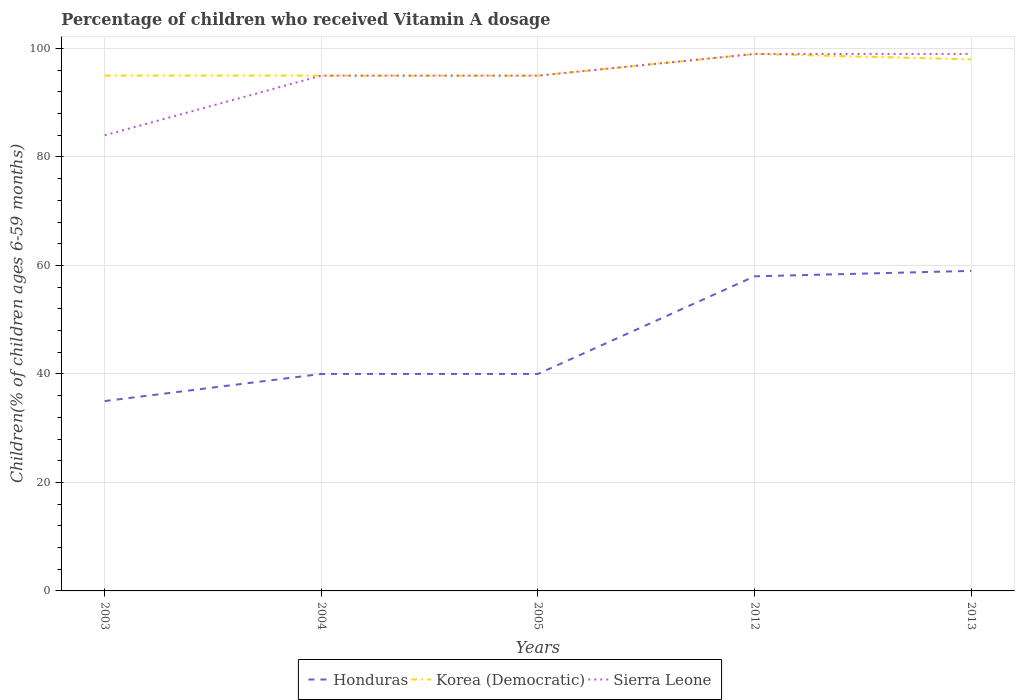How many different coloured lines are there?
Offer a very short reply. 3. Across all years, what is the maximum percentage of children who received Vitamin A dosage in Korea (Democratic)?
Give a very brief answer. 95. What is the total percentage of children who received Vitamin A dosage in Korea (Democratic) in the graph?
Provide a succinct answer. -4. What is the difference between the highest and the lowest percentage of children who received Vitamin A dosage in Korea (Democratic)?
Make the answer very short. 2. Is the percentage of children who received Vitamin A dosage in Sierra Leone strictly greater than the percentage of children who received Vitamin A dosage in Korea (Democratic) over the years?
Offer a terse response. No. How many years are there in the graph?
Your response must be concise. 5. Where does the legend appear in the graph?
Your answer should be very brief. Bottom center. What is the title of the graph?
Your answer should be compact. Percentage of children who received Vitamin A dosage. Does "Namibia" appear as one of the legend labels in the graph?
Offer a very short reply. No. What is the label or title of the X-axis?
Provide a short and direct response. Years. What is the label or title of the Y-axis?
Keep it short and to the point. Children(% of children ages 6-59 months). What is the Children(% of children ages 6-59 months) in Honduras in 2003?
Provide a short and direct response. 35. What is the Children(% of children ages 6-59 months) in Honduras in 2004?
Provide a succinct answer. 40. What is the Children(% of children ages 6-59 months) in Korea (Democratic) in 2004?
Offer a very short reply. 95. What is the Children(% of children ages 6-59 months) of Sierra Leone in 2004?
Keep it short and to the point. 95. What is the Children(% of children ages 6-59 months) in Sierra Leone in 2005?
Make the answer very short. 95. What is the Children(% of children ages 6-59 months) of Honduras in 2012?
Ensure brevity in your answer.  58. What is the Children(% of children ages 6-59 months) in Sierra Leone in 2012?
Provide a succinct answer. 99. What is the Children(% of children ages 6-59 months) of Honduras in 2013?
Your answer should be very brief. 59. What is the Children(% of children ages 6-59 months) of Korea (Democratic) in 2013?
Your response must be concise. 98. Across all years, what is the maximum Children(% of children ages 6-59 months) in Honduras?
Your answer should be compact. 59. Across all years, what is the maximum Children(% of children ages 6-59 months) in Korea (Democratic)?
Give a very brief answer. 99. Across all years, what is the minimum Children(% of children ages 6-59 months) of Honduras?
Ensure brevity in your answer.  35. Across all years, what is the minimum Children(% of children ages 6-59 months) in Korea (Democratic)?
Offer a terse response. 95. What is the total Children(% of children ages 6-59 months) of Honduras in the graph?
Offer a terse response. 232. What is the total Children(% of children ages 6-59 months) of Korea (Democratic) in the graph?
Make the answer very short. 482. What is the total Children(% of children ages 6-59 months) in Sierra Leone in the graph?
Provide a short and direct response. 472. What is the difference between the Children(% of children ages 6-59 months) in Korea (Democratic) in 2003 and that in 2004?
Provide a succinct answer. 0. What is the difference between the Children(% of children ages 6-59 months) in Honduras in 2003 and that in 2005?
Your answer should be compact. -5. What is the difference between the Children(% of children ages 6-59 months) in Sierra Leone in 2003 and that in 2005?
Your response must be concise. -11. What is the difference between the Children(% of children ages 6-59 months) in Honduras in 2003 and that in 2012?
Your response must be concise. -23. What is the difference between the Children(% of children ages 6-59 months) in Korea (Democratic) in 2003 and that in 2012?
Your answer should be compact. -4. What is the difference between the Children(% of children ages 6-59 months) in Honduras in 2003 and that in 2013?
Offer a terse response. -24. What is the difference between the Children(% of children ages 6-59 months) of Honduras in 2004 and that in 2005?
Provide a succinct answer. 0. What is the difference between the Children(% of children ages 6-59 months) of Sierra Leone in 2004 and that in 2005?
Make the answer very short. 0. What is the difference between the Children(% of children ages 6-59 months) in Korea (Democratic) in 2004 and that in 2012?
Offer a terse response. -4. What is the difference between the Children(% of children ages 6-59 months) of Sierra Leone in 2004 and that in 2012?
Make the answer very short. -4. What is the difference between the Children(% of children ages 6-59 months) in Honduras in 2004 and that in 2013?
Make the answer very short. -19. What is the difference between the Children(% of children ages 6-59 months) of Korea (Democratic) in 2004 and that in 2013?
Provide a succinct answer. -3. What is the difference between the Children(% of children ages 6-59 months) in Honduras in 2005 and that in 2012?
Make the answer very short. -18. What is the difference between the Children(% of children ages 6-59 months) in Korea (Democratic) in 2005 and that in 2012?
Offer a very short reply. -4. What is the difference between the Children(% of children ages 6-59 months) in Korea (Democratic) in 2005 and that in 2013?
Provide a succinct answer. -3. What is the difference between the Children(% of children ages 6-59 months) of Korea (Democratic) in 2012 and that in 2013?
Keep it short and to the point. 1. What is the difference between the Children(% of children ages 6-59 months) in Honduras in 2003 and the Children(% of children ages 6-59 months) in Korea (Democratic) in 2004?
Give a very brief answer. -60. What is the difference between the Children(% of children ages 6-59 months) in Honduras in 2003 and the Children(% of children ages 6-59 months) in Sierra Leone in 2004?
Your answer should be compact. -60. What is the difference between the Children(% of children ages 6-59 months) in Honduras in 2003 and the Children(% of children ages 6-59 months) in Korea (Democratic) in 2005?
Offer a terse response. -60. What is the difference between the Children(% of children ages 6-59 months) of Honduras in 2003 and the Children(% of children ages 6-59 months) of Sierra Leone in 2005?
Keep it short and to the point. -60. What is the difference between the Children(% of children ages 6-59 months) in Korea (Democratic) in 2003 and the Children(% of children ages 6-59 months) in Sierra Leone in 2005?
Provide a succinct answer. 0. What is the difference between the Children(% of children ages 6-59 months) of Honduras in 2003 and the Children(% of children ages 6-59 months) of Korea (Democratic) in 2012?
Make the answer very short. -64. What is the difference between the Children(% of children ages 6-59 months) in Honduras in 2003 and the Children(% of children ages 6-59 months) in Sierra Leone in 2012?
Your response must be concise. -64. What is the difference between the Children(% of children ages 6-59 months) of Honduras in 2003 and the Children(% of children ages 6-59 months) of Korea (Democratic) in 2013?
Your answer should be very brief. -63. What is the difference between the Children(% of children ages 6-59 months) of Honduras in 2003 and the Children(% of children ages 6-59 months) of Sierra Leone in 2013?
Provide a succinct answer. -64. What is the difference between the Children(% of children ages 6-59 months) in Korea (Democratic) in 2003 and the Children(% of children ages 6-59 months) in Sierra Leone in 2013?
Offer a very short reply. -4. What is the difference between the Children(% of children ages 6-59 months) in Honduras in 2004 and the Children(% of children ages 6-59 months) in Korea (Democratic) in 2005?
Give a very brief answer. -55. What is the difference between the Children(% of children ages 6-59 months) in Honduras in 2004 and the Children(% of children ages 6-59 months) in Sierra Leone in 2005?
Your answer should be very brief. -55. What is the difference between the Children(% of children ages 6-59 months) in Korea (Democratic) in 2004 and the Children(% of children ages 6-59 months) in Sierra Leone in 2005?
Keep it short and to the point. 0. What is the difference between the Children(% of children ages 6-59 months) of Honduras in 2004 and the Children(% of children ages 6-59 months) of Korea (Democratic) in 2012?
Ensure brevity in your answer.  -59. What is the difference between the Children(% of children ages 6-59 months) in Honduras in 2004 and the Children(% of children ages 6-59 months) in Sierra Leone in 2012?
Your response must be concise. -59. What is the difference between the Children(% of children ages 6-59 months) in Korea (Democratic) in 2004 and the Children(% of children ages 6-59 months) in Sierra Leone in 2012?
Ensure brevity in your answer.  -4. What is the difference between the Children(% of children ages 6-59 months) of Honduras in 2004 and the Children(% of children ages 6-59 months) of Korea (Democratic) in 2013?
Provide a succinct answer. -58. What is the difference between the Children(% of children ages 6-59 months) of Honduras in 2004 and the Children(% of children ages 6-59 months) of Sierra Leone in 2013?
Your response must be concise. -59. What is the difference between the Children(% of children ages 6-59 months) of Korea (Democratic) in 2004 and the Children(% of children ages 6-59 months) of Sierra Leone in 2013?
Provide a short and direct response. -4. What is the difference between the Children(% of children ages 6-59 months) in Honduras in 2005 and the Children(% of children ages 6-59 months) in Korea (Democratic) in 2012?
Give a very brief answer. -59. What is the difference between the Children(% of children ages 6-59 months) of Honduras in 2005 and the Children(% of children ages 6-59 months) of Sierra Leone in 2012?
Provide a short and direct response. -59. What is the difference between the Children(% of children ages 6-59 months) of Korea (Democratic) in 2005 and the Children(% of children ages 6-59 months) of Sierra Leone in 2012?
Provide a short and direct response. -4. What is the difference between the Children(% of children ages 6-59 months) in Honduras in 2005 and the Children(% of children ages 6-59 months) in Korea (Democratic) in 2013?
Ensure brevity in your answer.  -58. What is the difference between the Children(% of children ages 6-59 months) in Honduras in 2005 and the Children(% of children ages 6-59 months) in Sierra Leone in 2013?
Ensure brevity in your answer.  -59. What is the difference between the Children(% of children ages 6-59 months) of Honduras in 2012 and the Children(% of children ages 6-59 months) of Sierra Leone in 2013?
Your answer should be compact. -41. What is the difference between the Children(% of children ages 6-59 months) in Korea (Democratic) in 2012 and the Children(% of children ages 6-59 months) in Sierra Leone in 2013?
Offer a very short reply. 0. What is the average Children(% of children ages 6-59 months) of Honduras per year?
Your answer should be very brief. 46.4. What is the average Children(% of children ages 6-59 months) of Korea (Democratic) per year?
Your answer should be compact. 96.4. What is the average Children(% of children ages 6-59 months) of Sierra Leone per year?
Your answer should be very brief. 94.4. In the year 2003, what is the difference between the Children(% of children ages 6-59 months) of Honduras and Children(% of children ages 6-59 months) of Korea (Democratic)?
Provide a short and direct response. -60. In the year 2003, what is the difference between the Children(% of children ages 6-59 months) in Honduras and Children(% of children ages 6-59 months) in Sierra Leone?
Provide a succinct answer. -49. In the year 2004, what is the difference between the Children(% of children ages 6-59 months) of Honduras and Children(% of children ages 6-59 months) of Korea (Democratic)?
Offer a terse response. -55. In the year 2004, what is the difference between the Children(% of children ages 6-59 months) in Honduras and Children(% of children ages 6-59 months) in Sierra Leone?
Your answer should be very brief. -55. In the year 2004, what is the difference between the Children(% of children ages 6-59 months) in Korea (Democratic) and Children(% of children ages 6-59 months) in Sierra Leone?
Make the answer very short. 0. In the year 2005, what is the difference between the Children(% of children ages 6-59 months) in Honduras and Children(% of children ages 6-59 months) in Korea (Democratic)?
Your response must be concise. -55. In the year 2005, what is the difference between the Children(% of children ages 6-59 months) of Honduras and Children(% of children ages 6-59 months) of Sierra Leone?
Give a very brief answer. -55. In the year 2005, what is the difference between the Children(% of children ages 6-59 months) in Korea (Democratic) and Children(% of children ages 6-59 months) in Sierra Leone?
Your response must be concise. 0. In the year 2012, what is the difference between the Children(% of children ages 6-59 months) of Honduras and Children(% of children ages 6-59 months) of Korea (Democratic)?
Your answer should be compact. -41. In the year 2012, what is the difference between the Children(% of children ages 6-59 months) of Honduras and Children(% of children ages 6-59 months) of Sierra Leone?
Provide a succinct answer. -41. In the year 2012, what is the difference between the Children(% of children ages 6-59 months) of Korea (Democratic) and Children(% of children ages 6-59 months) of Sierra Leone?
Your answer should be very brief. 0. In the year 2013, what is the difference between the Children(% of children ages 6-59 months) of Honduras and Children(% of children ages 6-59 months) of Korea (Democratic)?
Ensure brevity in your answer.  -39. What is the ratio of the Children(% of children ages 6-59 months) of Honduras in 2003 to that in 2004?
Offer a terse response. 0.88. What is the ratio of the Children(% of children ages 6-59 months) in Sierra Leone in 2003 to that in 2004?
Give a very brief answer. 0.88. What is the ratio of the Children(% of children ages 6-59 months) in Honduras in 2003 to that in 2005?
Keep it short and to the point. 0.88. What is the ratio of the Children(% of children ages 6-59 months) in Sierra Leone in 2003 to that in 2005?
Offer a very short reply. 0.88. What is the ratio of the Children(% of children ages 6-59 months) in Honduras in 2003 to that in 2012?
Offer a very short reply. 0.6. What is the ratio of the Children(% of children ages 6-59 months) of Korea (Democratic) in 2003 to that in 2012?
Offer a terse response. 0.96. What is the ratio of the Children(% of children ages 6-59 months) in Sierra Leone in 2003 to that in 2012?
Your answer should be very brief. 0.85. What is the ratio of the Children(% of children ages 6-59 months) of Honduras in 2003 to that in 2013?
Provide a short and direct response. 0.59. What is the ratio of the Children(% of children ages 6-59 months) in Korea (Democratic) in 2003 to that in 2013?
Make the answer very short. 0.97. What is the ratio of the Children(% of children ages 6-59 months) in Sierra Leone in 2003 to that in 2013?
Your answer should be compact. 0.85. What is the ratio of the Children(% of children ages 6-59 months) in Honduras in 2004 to that in 2012?
Keep it short and to the point. 0.69. What is the ratio of the Children(% of children ages 6-59 months) in Korea (Democratic) in 2004 to that in 2012?
Your answer should be compact. 0.96. What is the ratio of the Children(% of children ages 6-59 months) in Sierra Leone in 2004 to that in 2012?
Ensure brevity in your answer.  0.96. What is the ratio of the Children(% of children ages 6-59 months) in Honduras in 2004 to that in 2013?
Keep it short and to the point. 0.68. What is the ratio of the Children(% of children ages 6-59 months) in Korea (Democratic) in 2004 to that in 2013?
Offer a terse response. 0.97. What is the ratio of the Children(% of children ages 6-59 months) of Sierra Leone in 2004 to that in 2013?
Make the answer very short. 0.96. What is the ratio of the Children(% of children ages 6-59 months) in Honduras in 2005 to that in 2012?
Give a very brief answer. 0.69. What is the ratio of the Children(% of children ages 6-59 months) in Korea (Democratic) in 2005 to that in 2012?
Ensure brevity in your answer.  0.96. What is the ratio of the Children(% of children ages 6-59 months) in Sierra Leone in 2005 to that in 2012?
Offer a very short reply. 0.96. What is the ratio of the Children(% of children ages 6-59 months) of Honduras in 2005 to that in 2013?
Your response must be concise. 0.68. What is the ratio of the Children(% of children ages 6-59 months) in Korea (Democratic) in 2005 to that in 2013?
Make the answer very short. 0.97. What is the ratio of the Children(% of children ages 6-59 months) in Sierra Leone in 2005 to that in 2013?
Ensure brevity in your answer.  0.96. What is the ratio of the Children(% of children ages 6-59 months) in Honduras in 2012 to that in 2013?
Offer a terse response. 0.98. What is the ratio of the Children(% of children ages 6-59 months) in Korea (Democratic) in 2012 to that in 2013?
Give a very brief answer. 1.01. What is the ratio of the Children(% of children ages 6-59 months) of Sierra Leone in 2012 to that in 2013?
Your answer should be very brief. 1. What is the difference between the highest and the second highest Children(% of children ages 6-59 months) in Honduras?
Offer a very short reply. 1. What is the difference between the highest and the lowest Children(% of children ages 6-59 months) of Korea (Democratic)?
Ensure brevity in your answer.  4. 